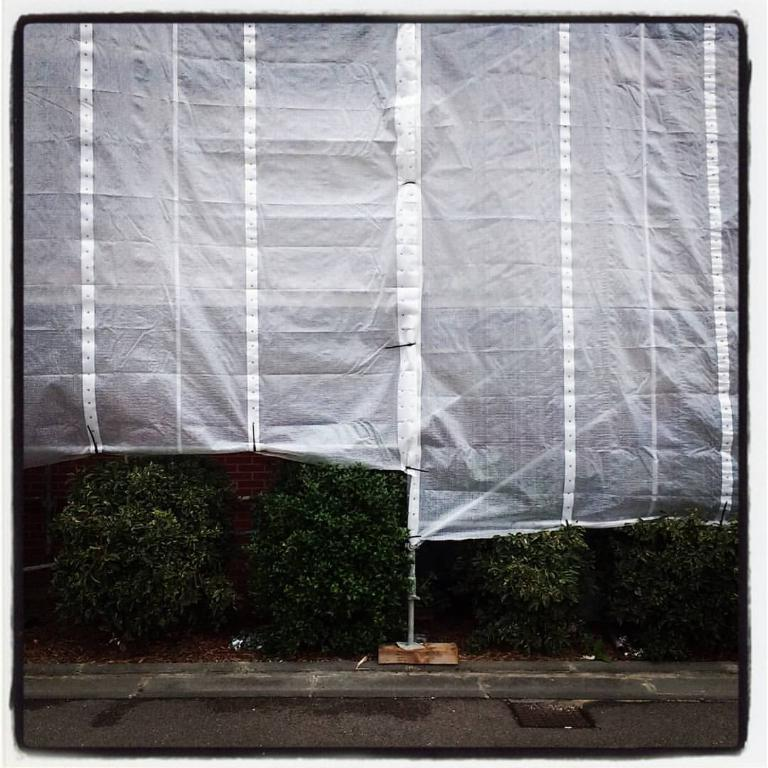What type of natural elements can be seen in the image? There are trees in the image. What type of man-made structure is visible in the image? There is a road in the image. What type of object is covering something in the image? There is a plastic cover in the image. What type of gold object can be seen in the image? There is no gold object present in the image. Can you provide an example of a structure that is not visible in the image? It is not possible to provide an example of a structure that is not visible in the image, as we can only discuss the elements that are present in the image. 